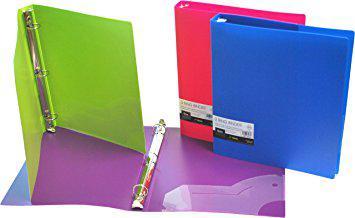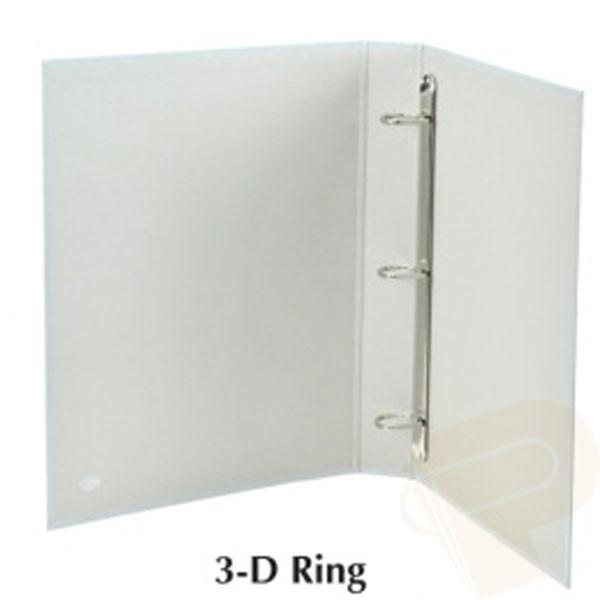The first image is the image on the left, the second image is the image on the right. For the images shown, is this caption "One image includes at least one closed, upright binder next to an open upright binder, and the combined images contain at least some non-white binders." true? Answer yes or no. Yes. The first image is the image on the left, the second image is the image on the right. For the images displayed, is the sentence "There are no more than two binders shown." factually correct? Answer yes or no. No. 